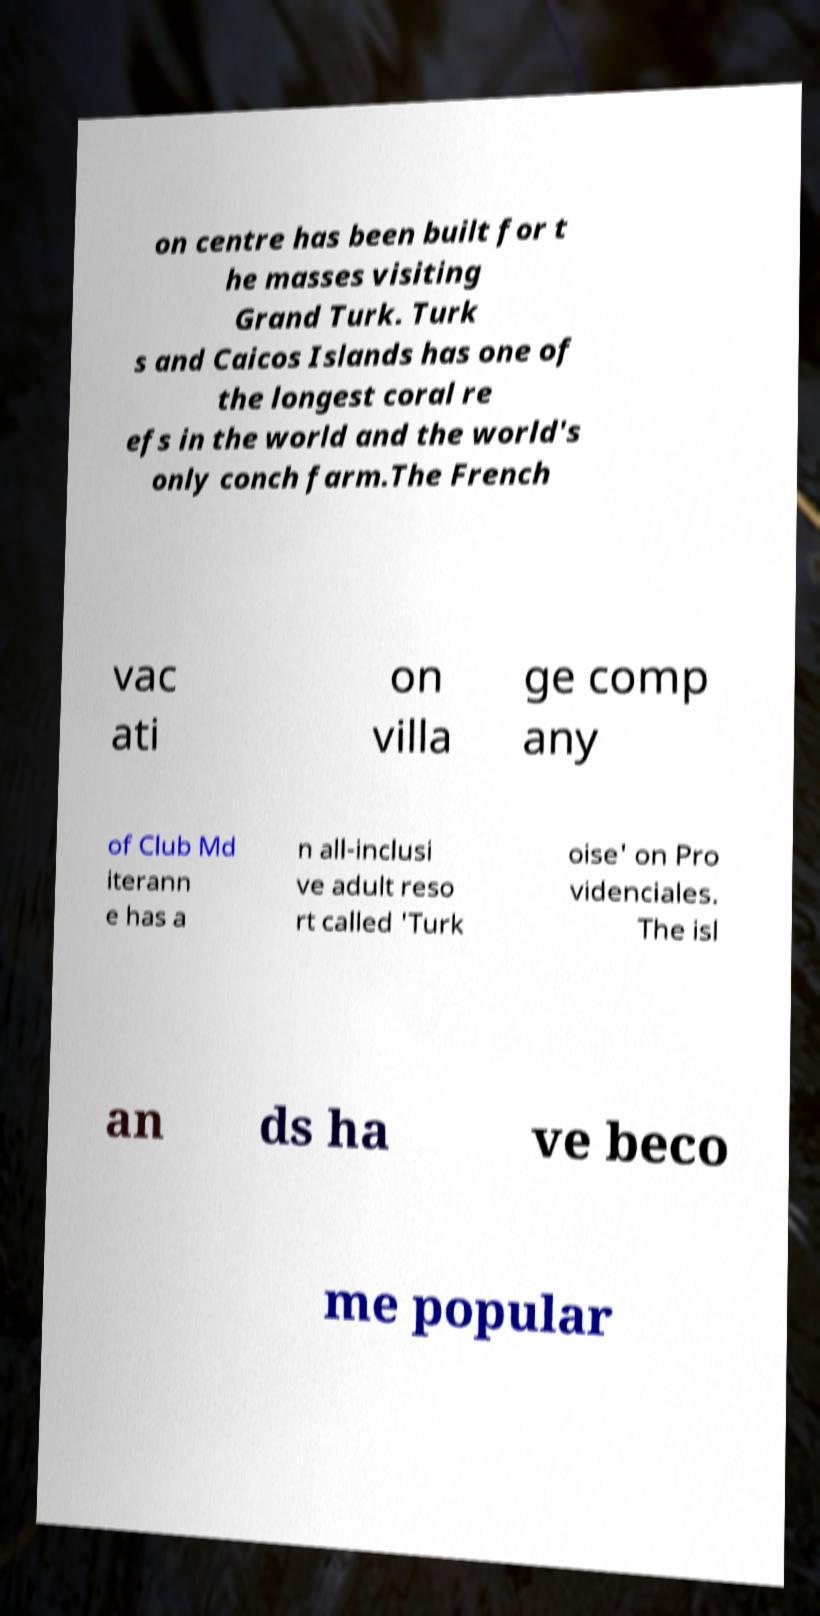Please read and relay the text visible in this image. What does it say? on centre has been built for t he masses visiting Grand Turk. Turk s and Caicos Islands has one of the longest coral re efs in the world and the world's only conch farm.The French vac ati on villa ge comp any of Club Md iterann e has a n all-inclusi ve adult reso rt called 'Turk oise' on Pro videnciales. The isl an ds ha ve beco me popular 